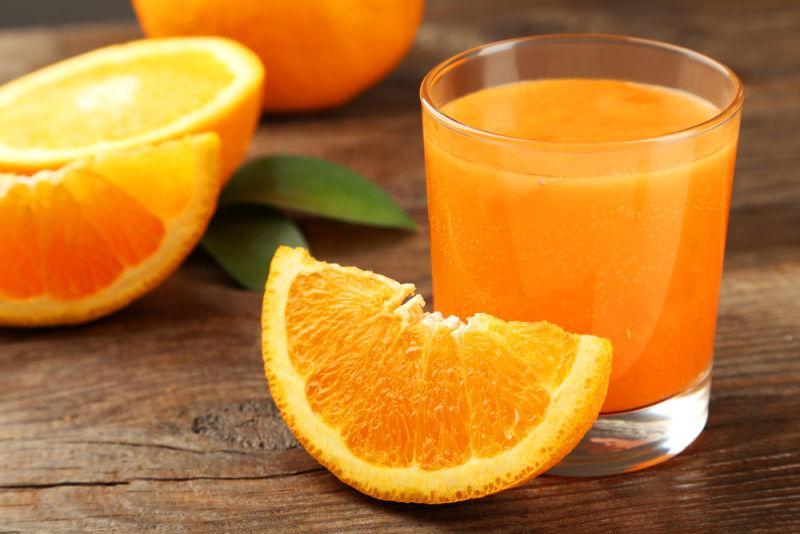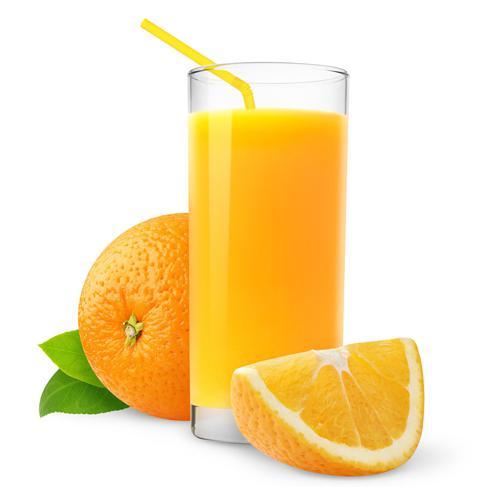The first image is the image on the left, the second image is the image on the right. Assess this claim about the two images: "Some of the oranges are cut into wedges, not just halves.". Correct or not? Answer yes or no. Yes. The first image is the image on the left, the second image is the image on the right. Given the left and right images, does the statement "Only one image contains the juice of the oranges." hold true? Answer yes or no. No. 